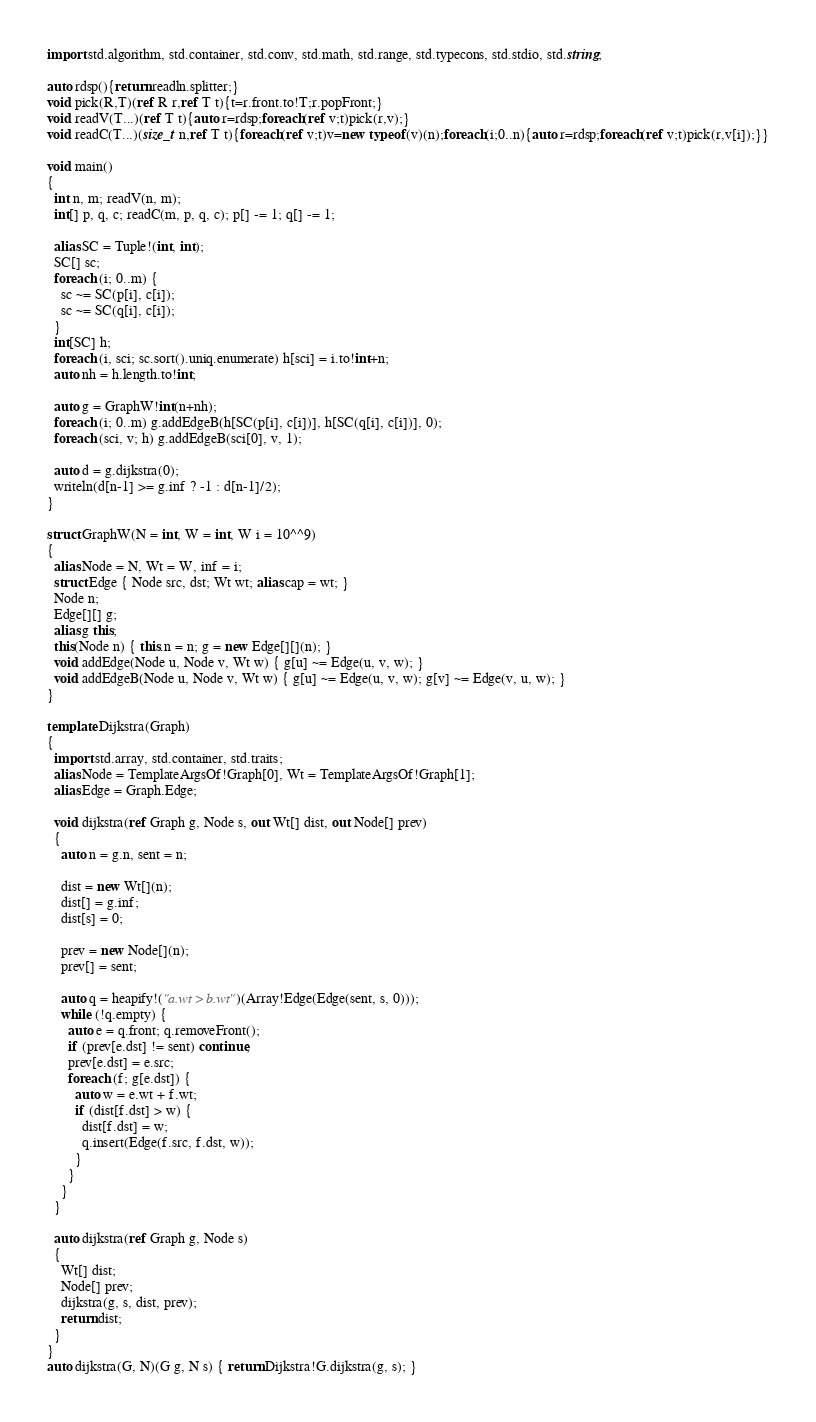<code> <loc_0><loc_0><loc_500><loc_500><_D_>import std.algorithm, std.container, std.conv, std.math, std.range, std.typecons, std.stdio, std.string;

auto rdsp(){return readln.splitter;}
void pick(R,T)(ref R r,ref T t){t=r.front.to!T;r.popFront;}
void readV(T...)(ref T t){auto r=rdsp;foreach(ref v;t)pick(r,v);}
void readC(T...)(size_t n,ref T t){foreach(ref v;t)v=new typeof(v)(n);foreach(i;0..n){auto r=rdsp;foreach(ref v;t)pick(r,v[i]);}}

void main()
{
  int n, m; readV(n, m);
  int[] p, q, c; readC(m, p, q, c); p[] -= 1; q[] -= 1;
 
  alias SC = Tuple!(int, int);
  SC[] sc;
  foreach (i; 0..m) {
    sc ~= SC(p[i], c[i]);
    sc ~= SC(q[i], c[i]);
  }
  int[SC] h;
  foreach (i, sci; sc.sort().uniq.enumerate) h[sci] = i.to!int+n;
  auto nh = h.length.to!int;
 
  auto g = GraphW!int(n+nh);
  foreach (i; 0..m) g.addEdgeB(h[SC(p[i], c[i])], h[SC(q[i], c[i])], 0);
  foreach (sci, v; h) g.addEdgeB(sci[0], v, 1);
 
  auto d = g.dijkstra(0);
  writeln(d[n-1] >= g.inf ? -1 : d[n-1]/2);
}

struct GraphW(N = int, W = int, W i = 10^^9)
{
  alias Node = N, Wt = W, inf = i;
  struct Edge { Node src, dst; Wt wt; alias cap = wt; }
  Node n;
  Edge[][] g;
  alias g this;
  this(Node n) { this.n = n; g = new Edge[][](n); }
  void addEdge(Node u, Node v, Wt w) { g[u] ~= Edge(u, v, w); }
  void addEdgeB(Node u, Node v, Wt w) { g[u] ~= Edge(u, v, w); g[v] ~= Edge(v, u, w); }
}

template Dijkstra(Graph)
{
  import std.array, std.container, std.traits;
  alias Node = TemplateArgsOf!Graph[0], Wt = TemplateArgsOf!Graph[1];
  alias Edge = Graph.Edge;

  void dijkstra(ref Graph g, Node s, out Wt[] dist, out Node[] prev)
  {
    auto n = g.n, sent = n;

    dist = new Wt[](n);
    dist[] = g.inf;
    dist[s] = 0;

    prev = new Node[](n);
    prev[] = sent;

    auto q = heapify!("a.wt > b.wt")(Array!Edge(Edge(sent, s, 0)));
    while (!q.empty) {
      auto e = q.front; q.removeFront();
      if (prev[e.dst] != sent) continue;
      prev[e.dst] = e.src;
      foreach (f; g[e.dst]) {
        auto w = e.wt + f.wt;
        if (dist[f.dst] > w) {
          dist[f.dst] = w;
          q.insert(Edge(f.src, f.dst, w));
        }
      }
    }
  }

  auto dijkstra(ref Graph g, Node s)
  {
    Wt[] dist;
    Node[] prev;
    dijkstra(g, s, dist, prev);
    return dist;
  }
}
auto dijkstra(G, N)(G g, N s) { return Dijkstra!G.dijkstra(g, s); }
</code> 